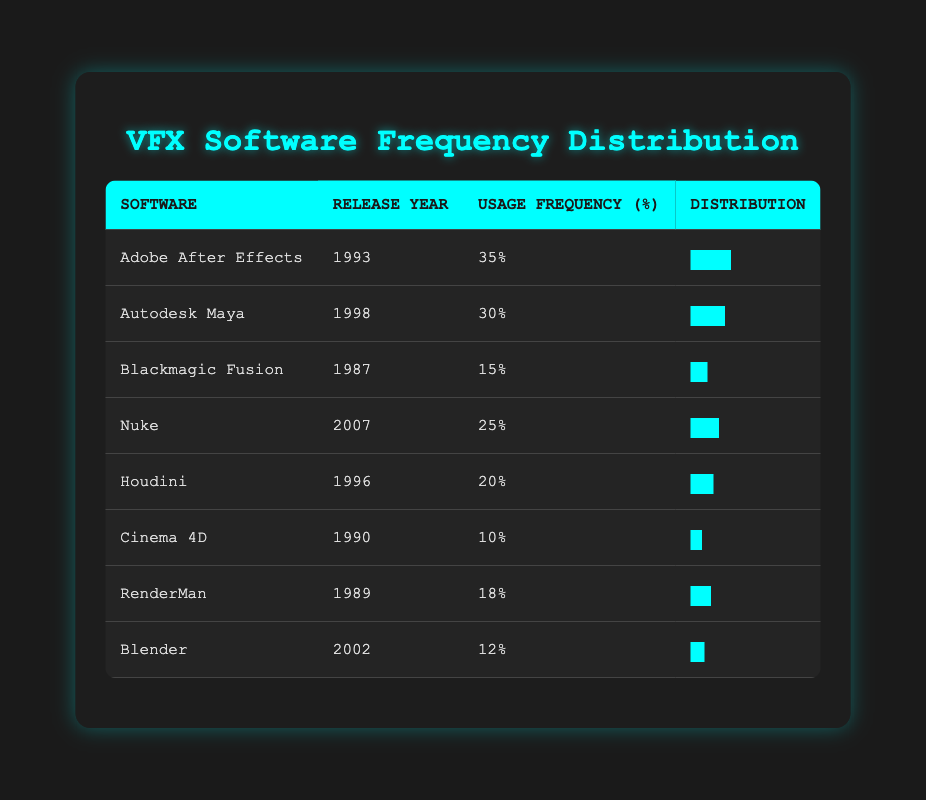What is the software with the highest usage frequency? By looking at the "Usage Frequency (%)" column, the highest value is 35%, which corresponds to "Adobe After Effects."
Answer: Adobe After Effects Which software was released first, Blackmagic Fusion or RenderMan? Checking the "Release Year" column, Blackmagic Fusion was released in 1987 and RenderMan in 1989. Therefore, Blackmagic Fusion was released first.
Answer: Blackmagic Fusion What is the total usage frequency of the software released in the 1990s? To find this, we identify the software from the 1990s: Adobe After Effects (35), Houdini (20), Autodesk Maya (30), and Cinema 4D (10). Adding these gives 35 + 20 + 30 + 10 = 95%.
Answer: 95 Is it true that all software listed has a usage frequency of at least 10%? Checking each software's usage frequency, we see that Blender has a usage frequency of 12%, and Cinema 4D has the lowest at 10%. All listed software has at least a 10% usage frequency.
Answer: Yes What is the average usage frequency of the software released after the year 2000? The software released after 2000 are Nuke (25) and Blender (12). To find the average, we add the values: 25 + 12 = 37, and then divide by the number of software, which is 2. The average is 37/2 = 18.5%.
Answer: 18.5 